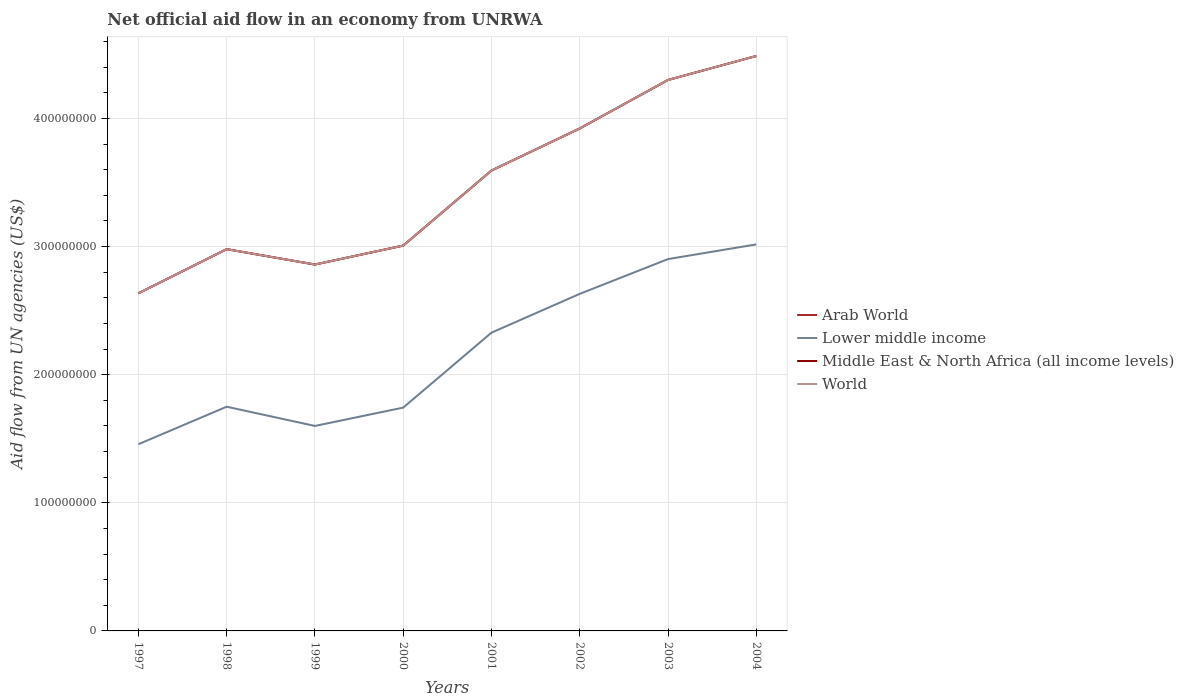Across all years, what is the maximum net official aid flow in Arab World?
Keep it short and to the point. 2.64e+08. In which year was the net official aid flow in Middle East & North Africa (all income levels) maximum?
Offer a terse response. 1997. What is the total net official aid flow in Lower middle income in the graph?
Offer a very short reply. -1.30e+08. What is the difference between the highest and the second highest net official aid flow in World?
Your response must be concise. 1.85e+08. What is the difference between two consecutive major ticks on the Y-axis?
Your answer should be compact. 1.00e+08. Are the values on the major ticks of Y-axis written in scientific E-notation?
Offer a terse response. No. Does the graph contain grids?
Give a very brief answer. Yes. Where does the legend appear in the graph?
Offer a very short reply. Center right. How many legend labels are there?
Keep it short and to the point. 4. What is the title of the graph?
Offer a terse response. Net official aid flow in an economy from UNRWA. What is the label or title of the X-axis?
Offer a terse response. Years. What is the label or title of the Y-axis?
Keep it short and to the point. Aid flow from UN agencies (US$). What is the Aid flow from UN agencies (US$) in Arab World in 1997?
Make the answer very short. 2.64e+08. What is the Aid flow from UN agencies (US$) of Lower middle income in 1997?
Your answer should be very brief. 1.46e+08. What is the Aid flow from UN agencies (US$) in Middle East & North Africa (all income levels) in 1997?
Provide a succinct answer. 2.64e+08. What is the Aid flow from UN agencies (US$) of World in 1997?
Your response must be concise. 2.64e+08. What is the Aid flow from UN agencies (US$) in Arab World in 1998?
Your answer should be compact. 2.98e+08. What is the Aid flow from UN agencies (US$) in Lower middle income in 1998?
Provide a short and direct response. 1.75e+08. What is the Aid flow from UN agencies (US$) of Middle East & North Africa (all income levels) in 1998?
Give a very brief answer. 2.98e+08. What is the Aid flow from UN agencies (US$) of World in 1998?
Your answer should be very brief. 2.98e+08. What is the Aid flow from UN agencies (US$) of Arab World in 1999?
Provide a short and direct response. 2.86e+08. What is the Aid flow from UN agencies (US$) of Lower middle income in 1999?
Ensure brevity in your answer.  1.60e+08. What is the Aid flow from UN agencies (US$) in Middle East & North Africa (all income levels) in 1999?
Keep it short and to the point. 2.86e+08. What is the Aid flow from UN agencies (US$) in World in 1999?
Keep it short and to the point. 2.86e+08. What is the Aid flow from UN agencies (US$) in Arab World in 2000?
Keep it short and to the point. 3.01e+08. What is the Aid flow from UN agencies (US$) in Lower middle income in 2000?
Your response must be concise. 1.74e+08. What is the Aid flow from UN agencies (US$) in Middle East & North Africa (all income levels) in 2000?
Your answer should be very brief. 3.01e+08. What is the Aid flow from UN agencies (US$) in World in 2000?
Offer a terse response. 3.01e+08. What is the Aid flow from UN agencies (US$) of Arab World in 2001?
Ensure brevity in your answer.  3.59e+08. What is the Aid flow from UN agencies (US$) in Lower middle income in 2001?
Ensure brevity in your answer.  2.33e+08. What is the Aid flow from UN agencies (US$) of Middle East & North Africa (all income levels) in 2001?
Ensure brevity in your answer.  3.59e+08. What is the Aid flow from UN agencies (US$) of World in 2001?
Your response must be concise. 3.59e+08. What is the Aid flow from UN agencies (US$) of Arab World in 2002?
Ensure brevity in your answer.  3.92e+08. What is the Aid flow from UN agencies (US$) in Lower middle income in 2002?
Offer a terse response. 2.63e+08. What is the Aid flow from UN agencies (US$) of Middle East & North Africa (all income levels) in 2002?
Keep it short and to the point. 3.92e+08. What is the Aid flow from UN agencies (US$) of World in 2002?
Make the answer very short. 3.92e+08. What is the Aid flow from UN agencies (US$) in Arab World in 2003?
Ensure brevity in your answer.  4.30e+08. What is the Aid flow from UN agencies (US$) of Lower middle income in 2003?
Provide a short and direct response. 2.90e+08. What is the Aid flow from UN agencies (US$) of Middle East & North Africa (all income levels) in 2003?
Offer a terse response. 4.30e+08. What is the Aid flow from UN agencies (US$) in World in 2003?
Offer a terse response. 4.30e+08. What is the Aid flow from UN agencies (US$) of Arab World in 2004?
Ensure brevity in your answer.  4.49e+08. What is the Aid flow from UN agencies (US$) in Lower middle income in 2004?
Make the answer very short. 3.02e+08. What is the Aid flow from UN agencies (US$) of Middle East & North Africa (all income levels) in 2004?
Provide a short and direct response. 4.49e+08. What is the Aid flow from UN agencies (US$) in World in 2004?
Provide a short and direct response. 4.49e+08. Across all years, what is the maximum Aid flow from UN agencies (US$) in Arab World?
Make the answer very short. 4.49e+08. Across all years, what is the maximum Aid flow from UN agencies (US$) in Lower middle income?
Give a very brief answer. 3.02e+08. Across all years, what is the maximum Aid flow from UN agencies (US$) in Middle East & North Africa (all income levels)?
Your response must be concise. 4.49e+08. Across all years, what is the maximum Aid flow from UN agencies (US$) of World?
Offer a terse response. 4.49e+08. Across all years, what is the minimum Aid flow from UN agencies (US$) in Arab World?
Keep it short and to the point. 2.64e+08. Across all years, what is the minimum Aid flow from UN agencies (US$) in Lower middle income?
Make the answer very short. 1.46e+08. Across all years, what is the minimum Aid flow from UN agencies (US$) of Middle East & North Africa (all income levels)?
Provide a succinct answer. 2.64e+08. Across all years, what is the minimum Aid flow from UN agencies (US$) of World?
Your response must be concise. 2.64e+08. What is the total Aid flow from UN agencies (US$) in Arab World in the graph?
Keep it short and to the point. 2.78e+09. What is the total Aid flow from UN agencies (US$) in Lower middle income in the graph?
Keep it short and to the point. 1.74e+09. What is the total Aid flow from UN agencies (US$) in Middle East & North Africa (all income levels) in the graph?
Make the answer very short. 2.78e+09. What is the total Aid flow from UN agencies (US$) of World in the graph?
Make the answer very short. 2.78e+09. What is the difference between the Aid flow from UN agencies (US$) of Arab World in 1997 and that in 1998?
Offer a terse response. -3.45e+07. What is the difference between the Aid flow from UN agencies (US$) of Lower middle income in 1997 and that in 1998?
Offer a terse response. -2.93e+07. What is the difference between the Aid flow from UN agencies (US$) in Middle East & North Africa (all income levels) in 1997 and that in 1998?
Make the answer very short. -3.45e+07. What is the difference between the Aid flow from UN agencies (US$) of World in 1997 and that in 1998?
Offer a terse response. -3.45e+07. What is the difference between the Aid flow from UN agencies (US$) of Arab World in 1997 and that in 1999?
Ensure brevity in your answer.  -2.25e+07. What is the difference between the Aid flow from UN agencies (US$) of Lower middle income in 1997 and that in 1999?
Your response must be concise. -1.43e+07. What is the difference between the Aid flow from UN agencies (US$) of Middle East & North Africa (all income levels) in 1997 and that in 1999?
Your answer should be compact. -2.25e+07. What is the difference between the Aid flow from UN agencies (US$) of World in 1997 and that in 1999?
Give a very brief answer. -2.25e+07. What is the difference between the Aid flow from UN agencies (US$) of Arab World in 1997 and that in 2000?
Offer a very short reply. -3.73e+07. What is the difference between the Aid flow from UN agencies (US$) of Lower middle income in 1997 and that in 2000?
Keep it short and to the point. -2.86e+07. What is the difference between the Aid flow from UN agencies (US$) in Middle East & North Africa (all income levels) in 1997 and that in 2000?
Your answer should be compact. -3.73e+07. What is the difference between the Aid flow from UN agencies (US$) of World in 1997 and that in 2000?
Make the answer very short. -3.73e+07. What is the difference between the Aid flow from UN agencies (US$) of Arab World in 1997 and that in 2001?
Give a very brief answer. -9.58e+07. What is the difference between the Aid flow from UN agencies (US$) in Lower middle income in 1997 and that in 2001?
Your answer should be compact. -8.71e+07. What is the difference between the Aid flow from UN agencies (US$) in Middle East & North Africa (all income levels) in 1997 and that in 2001?
Your response must be concise. -9.58e+07. What is the difference between the Aid flow from UN agencies (US$) of World in 1997 and that in 2001?
Keep it short and to the point. -9.58e+07. What is the difference between the Aid flow from UN agencies (US$) in Arab World in 1997 and that in 2002?
Offer a terse response. -1.29e+08. What is the difference between the Aid flow from UN agencies (US$) in Lower middle income in 1997 and that in 2002?
Make the answer very short. -1.17e+08. What is the difference between the Aid flow from UN agencies (US$) in Middle East & North Africa (all income levels) in 1997 and that in 2002?
Provide a short and direct response. -1.29e+08. What is the difference between the Aid flow from UN agencies (US$) in World in 1997 and that in 2002?
Your answer should be compact. -1.29e+08. What is the difference between the Aid flow from UN agencies (US$) of Arab World in 1997 and that in 2003?
Your answer should be very brief. -1.67e+08. What is the difference between the Aid flow from UN agencies (US$) in Lower middle income in 1997 and that in 2003?
Give a very brief answer. -1.45e+08. What is the difference between the Aid flow from UN agencies (US$) of Middle East & North Africa (all income levels) in 1997 and that in 2003?
Provide a succinct answer. -1.67e+08. What is the difference between the Aid flow from UN agencies (US$) in World in 1997 and that in 2003?
Your answer should be very brief. -1.67e+08. What is the difference between the Aid flow from UN agencies (US$) of Arab World in 1997 and that in 2004?
Your response must be concise. -1.85e+08. What is the difference between the Aid flow from UN agencies (US$) of Lower middle income in 1997 and that in 2004?
Offer a very short reply. -1.56e+08. What is the difference between the Aid flow from UN agencies (US$) in Middle East & North Africa (all income levels) in 1997 and that in 2004?
Offer a terse response. -1.85e+08. What is the difference between the Aid flow from UN agencies (US$) of World in 1997 and that in 2004?
Give a very brief answer. -1.85e+08. What is the difference between the Aid flow from UN agencies (US$) of Lower middle income in 1998 and that in 1999?
Offer a terse response. 1.50e+07. What is the difference between the Aid flow from UN agencies (US$) of Arab World in 1998 and that in 2000?
Your response must be concise. -2.78e+06. What is the difference between the Aid flow from UN agencies (US$) of Lower middle income in 1998 and that in 2000?
Keep it short and to the point. 6.90e+05. What is the difference between the Aid flow from UN agencies (US$) of Middle East & North Africa (all income levels) in 1998 and that in 2000?
Give a very brief answer. -2.78e+06. What is the difference between the Aid flow from UN agencies (US$) of World in 1998 and that in 2000?
Provide a succinct answer. -2.78e+06. What is the difference between the Aid flow from UN agencies (US$) in Arab World in 1998 and that in 2001?
Offer a very short reply. -6.14e+07. What is the difference between the Aid flow from UN agencies (US$) of Lower middle income in 1998 and that in 2001?
Keep it short and to the point. -5.78e+07. What is the difference between the Aid flow from UN agencies (US$) of Middle East & North Africa (all income levels) in 1998 and that in 2001?
Your answer should be compact. -6.14e+07. What is the difference between the Aid flow from UN agencies (US$) in World in 1998 and that in 2001?
Provide a short and direct response. -6.14e+07. What is the difference between the Aid flow from UN agencies (US$) in Arab World in 1998 and that in 2002?
Provide a short and direct response. -9.42e+07. What is the difference between the Aid flow from UN agencies (US$) in Lower middle income in 1998 and that in 2002?
Your answer should be compact. -8.81e+07. What is the difference between the Aid flow from UN agencies (US$) of Middle East & North Africa (all income levels) in 1998 and that in 2002?
Keep it short and to the point. -9.42e+07. What is the difference between the Aid flow from UN agencies (US$) in World in 1998 and that in 2002?
Make the answer very short. -9.42e+07. What is the difference between the Aid flow from UN agencies (US$) of Arab World in 1998 and that in 2003?
Ensure brevity in your answer.  -1.32e+08. What is the difference between the Aid flow from UN agencies (US$) of Lower middle income in 1998 and that in 2003?
Keep it short and to the point. -1.15e+08. What is the difference between the Aid flow from UN agencies (US$) of Middle East & North Africa (all income levels) in 1998 and that in 2003?
Provide a short and direct response. -1.32e+08. What is the difference between the Aid flow from UN agencies (US$) of World in 1998 and that in 2003?
Provide a succinct answer. -1.32e+08. What is the difference between the Aid flow from UN agencies (US$) in Arab World in 1998 and that in 2004?
Provide a short and direct response. -1.51e+08. What is the difference between the Aid flow from UN agencies (US$) in Lower middle income in 1998 and that in 2004?
Provide a short and direct response. -1.27e+08. What is the difference between the Aid flow from UN agencies (US$) in Middle East & North Africa (all income levels) in 1998 and that in 2004?
Ensure brevity in your answer.  -1.51e+08. What is the difference between the Aid flow from UN agencies (US$) in World in 1998 and that in 2004?
Provide a succinct answer. -1.51e+08. What is the difference between the Aid flow from UN agencies (US$) of Arab World in 1999 and that in 2000?
Keep it short and to the point. -1.48e+07. What is the difference between the Aid flow from UN agencies (US$) of Lower middle income in 1999 and that in 2000?
Provide a short and direct response. -1.43e+07. What is the difference between the Aid flow from UN agencies (US$) in Middle East & North Africa (all income levels) in 1999 and that in 2000?
Provide a succinct answer. -1.48e+07. What is the difference between the Aid flow from UN agencies (US$) in World in 1999 and that in 2000?
Offer a terse response. -1.48e+07. What is the difference between the Aid flow from UN agencies (US$) in Arab World in 1999 and that in 2001?
Offer a very short reply. -7.34e+07. What is the difference between the Aid flow from UN agencies (US$) in Lower middle income in 1999 and that in 2001?
Ensure brevity in your answer.  -7.28e+07. What is the difference between the Aid flow from UN agencies (US$) in Middle East & North Africa (all income levels) in 1999 and that in 2001?
Ensure brevity in your answer.  -7.34e+07. What is the difference between the Aid flow from UN agencies (US$) of World in 1999 and that in 2001?
Offer a terse response. -7.34e+07. What is the difference between the Aid flow from UN agencies (US$) of Arab World in 1999 and that in 2002?
Your answer should be compact. -1.06e+08. What is the difference between the Aid flow from UN agencies (US$) in Lower middle income in 1999 and that in 2002?
Ensure brevity in your answer.  -1.03e+08. What is the difference between the Aid flow from UN agencies (US$) in Middle East & North Africa (all income levels) in 1999 and that in 2002?
Give a very brief answer. -1.06e+08. What is the difference between the Aid flow from UN agencies (US$) in World in 1999 and that in 2002?
Your response must be concise. -1.06e+08. What is the difference between the Aid flow from UN agencies (US$) in Arab World in 1999 and that in 2003?
Give a very brief answer. -1.44e+08. What is the difference between the Aid flow from UN agencies (US$) in Lower middle income in 1999 and that in 2003?
Make the answer very short. -1.30e+08. What is the difference between the Aid flow from UN agencies (US$) of Middle East & North Africa (all income levels) in 1999 and that in 2003?
Offer a terse response. -1.44e+08. What is the difference between the Aid flow from UN agencies (US$) of World in 1999 and that in 2003?
Make the answer very short. -1.44e+08. What is the difference between the Aid flow from UN agencies (US$) in Arab World in 1999 and that in 2004?
Give a very brief answer. -1.63e+08. What is the difference between the Aid flow from UN agencies (US$) of Lower middle income in 1999 and that in 2004?
Offer a very short reply. -1.42e+08. What is the difference between the Aid flow from UN agencies (US$) of Middle East & North Africa (all income levels) in 1999 and that in 2004?
Offer a terse response. -1.63e+08. What is the difference between the Aid flow from UN agencies (US$) in World in 1999 and that in 2004?
Provide a short and direct response. -1.63e+08. What is the difference between the Aid flow from UN agencies (US$) in Arab World in 2000 and that in 2001?
Offer a terse response. -5.86e+07. What is the difference between the Aid flow from UN agencies (US$) in Lower middle income in 2000 and that in 2001?
Make the answer very short. -5.85e+07. What is the difference between the Aid flow from UN agencies (US$) of Middle East & North Africa (all income levels) in 2000 and that in 2001?
Your answer should be compact. -5.86e+07. What is the difference between the Aid flow from UN agencies (US$) in World in 2000 and that in 2001?
Keep it short and to the point. -5.86e+07. What is the difference between the Aid flow from UN agencies (US$) of Arab World in 2000 and that in 2002?
Make the answer very short. -9.14e+07. What is the difference between the Aid flow from UN agencies (US$) in Lower middle income in 2000 and that in 2002?
Offer a very short reply. -8.88e+07. What is the difference between the Aid flow from UN agencies (US$) in Middle East & North Africa (all income levels) in 2000 and that in 2002?
Your answer should be very brief. -9.14e+07. What is the difference between the Aid flow from UN agencies (US$) in World in 2000 and that in 2002?
Provide a succinct answer. -9.14e+07. What is the difference between the Aid flow from UN agencies (US$) of Arab World in 2000 and that in 2003?
Ensure brevity in your answer.  -1.29e+08. What is the difference between the Aid flow from UN agencies (US$) of Lower middle income in 2000 and that in 2003?
Your answer should be compact. -1.16e+08. What is the difference between the Aid flow from UN agencies (US$) of Middle East & North Africa (all income levels) in 2000 and that in 2003?
Keep it short and to the point. -1.29e+08. What is the difference between the Aid flow from UN agencies (US$) of World in 2000 and that in 2003?
Your answer should be very brief. -1.29e+08. What is the difference between the Aid flow from UN agencies (US$) of Arab World in 2000 and that in 2004?
Make the answer very short. -1.48e+08. What is the difference between the Aid flow from UN agencies (US$) in Lower middle income in 2000 and that in 2004?
Your answer should be very brief. -1.27e+08. What is the difference between the Aid flow from UN agencies (US$) in Middle East & North Africa (all income levels) in 2000 and that in 2004?
Offer a terse response. -1.48e+08. What is the difference between the Aid flow from UN agencies (US$) in World in 2000 and that in 2004?
Make the answer very short. -1.48e+08. What is the difference between the Aid flow from UN agencies (US$) of Arab World in 2001 and that in 2002?
Give a very brief answer. -3.28e+07. What is the difference between the Aid flow from UN agencies (US$) of Lower middle income in 2001 and that in 2002?
Offer a very short reply. -3.03e+07. What is the difference between the Aid flow from UN agencies (US$) of Middle East & North Africa (all income levels) in 2001 and that in 2002?
Make the answer very short. -3.28e+07. What is the difference between the Aid flow from UN agencies (US$) of World in 2001 and that in 2002?
Give a very brief answer. -3.28e+07. What is the difference between the Aid flow from UN agencies (US$) in Arab World in 2001 and that in 2003?
Provide a short and direct response. -7.07e+07. What is the difference between the Aid flow from UN agencies (US$) of Lower middle income in 2001 and that in 2003?
Provide a succinct answer. -5.74e+07. What is the difference between the Aid flow from UN agencies (US$) of Middle East & North Africa (all income levels) in 2001 and that in 2003?
Keep it short and to the point. -7.07e+07. What is the difference between the Aid flow from UN agencies (US$) of World in 2001 and that in 2003?
Make the answer very short. -7.07e+07. What is the difference between the Aid flow from UN agencies (US$) in Arab World in 2001 and that in 2004?
Offer a terse response. -8.94e+07. What is the difference between the Aid flow from UN agencies (US$) of Lower middle income in 2001 and that in 2004?
Offer a terse response. -6.89e+07. What is the difference between the Aid flow from UN agencies (US$) in Middle East & North Africa (all income levels) in 2001 and that in 2004?
Offer a terse response. -8.94e+07. What is the difference between the Aid flow from UN agencies (US$) of World in 2001 and that in 2004?
Provide a short and direct response. -8.94e+07. What is the difference between the Aid flow from UN agencies (US$) in Arab World in 2002 and that in 2003?
Make the answer very short. -3.79e+07. What is the difference between the Aid flow from UN agencies (US$) of Lower middle income in 2002 and that in 2003?
Provide a short and direct response. -2.72e+07. What is the difference between the Aid flow from UN agencies (US$) in Middle East & North Africa (all income levels) in 2002 and that in 2003?
Provide a succinct answer. -3.79e+07. What is the difference between the Aid flow from UN agencies (US$) of World in 2002 and that in 2003?
Your answer should be very brief. -3.79e+07. What is the difference between the Aid flow from UN agencies (US$) in Arab World in 2002 and that in 2004?
Offer a terse response. -5.66e+07. What is the difference between the Aid flow from UN agencies (US$) in Lower middle income in 2002 and that in 2004?
Give a very brief answer. -3.86e+07. What is the difference between the Aid flow from UN agencies (US$) of Middle East & North Africa (all income levels) in 2002 and that in 2004?
Your answer should be very brief. -5.66e+07. What is the difference between the Aid flow from UN agencies (US$) of World in 2002 and that in 2004?
Keep it short and to the point. -5.66e+07. What is the difference between the Aid flow from UN agencies (US$) of Arab World in 2003 and that in 2004?
Provide a short and direct response. -1.87e+07. What is the difference between the Aid flow from UN agencies (US$) of Lower middle income in 2003 and that in 2004?
Your answer should be very brief. -1.15e+07. What is the difference between the Aid flow from UN agencies (US$) of Middle East & North Africa (all income levels) in 2003 and that in 2004?
Your answer should be very brief. -1.87e+07. What is the difference between the Aid flow from UN agencies (US$) of World in 2003 and that in 2004?
Offer a terse response. -1.87e+07. What is the difference between the Aid flow from UN agencies (US$) of Arab World in 1997 and the Aid flow from UN agencies (US$) of Lower middle income in 1998?
Your answer should be very brief. 8.85e+07. What is the difference between the Aid flow from UN agencies (US$) of Arab World in 1997 and the Aid flow from UN agencies (US$) of Middle East & North Africa (all income levels) in 1998?
Your response must be concise. -3.45e+07. What is the difference between the Aid flow from UN agencies (US$) of Arab World in 1997 and the Aid flow from UN agencies (US$) of World in 1998?
Your answer should be very brief. -3.45e+07. What is the difference between the Aid flow from UN agencies (US$) of Lower middle income in 1997 and the Aid flow from UN agencies (US$) of Middle East & North Africa (all income levels) in 1998?
Give a very brief answer. -1.52e+08. What is the difference between the Aid flow from UN agencies (US$) of Lower middle income in 1997 and the Aid flow from UN agencies (US$) of World in 1998?
Give a very brief answer. -1.52e+08. What is the difference between the Aid flow from UN agencies (US$) of Middle East & North Africa (all income levels) in 1997 and the Aid flow from UN agencies (US$) of World in 1998?
Your answer should be compact. -3.45e+07. What is the difference between the Aid flow from UN agencies (US$) in Arab World in 1997 and the Aid flow from UN agencies (US$) in Lower middle income in 1999?
Ensure brevity in your answer.  1.04e+08. What is the difference between the Aid flow from UN agencies (US$) of Arab World in 1997 and the Aid flow from UN agencies (US$) of Middle East & North Africa (all income levels) in 1999?
Offer a very short reply. -2.25e+07. What is the difference between the Aid flow from UN agencies (US$) of Arab World in 1997 and the Aid flow from UN agencies (US$) of World in 1999?
Your answer should be compact. -2.25e+07. What is the difference between the Aid flow from UN agencies (US$) in Lower middle income in 1997 and the Aid flow from UN agencies (US$) in Middle East & North Africa (all income levels) in 1999?
Your answer should be compact. -1.40e+08. What is the difference between the Aid flow from UN agencies (US$) in Lower middle income in 1997 and the Aid flow from UN agencies (US$) in World in 1999?
Offer a terse response. -1.40e+08. What is the difference between the Aid flow from UN agencies (US$) of Middle East & North Africa (all income levels) in 1997 and the Aid flow from UN agencies (US$) of World in 1999?
Your answer should be very brief. -2.25e+07. What is the difference between the Aid flow from UN agencies (US$) in Arab World in 1997 and the Aid flow from UN agencies (US$) in Lower middle income in 2000?
Give a very brief answer. 8.92e+07. What is the difference between the Aid flow from UN agencies (US$) in Arab World in 1997 and the Aid flow from UN agencies (US$) in Middle East & North Africa (all income levels) in 2000?
Your response must be concise. -3.73e+07. What is the difference between the Aid flow from UN agencies (US$) of Arab World in 1997 and the Aid flow from UN agencies (US$) of World in 2000?
Provide a short and direct response. -3.73e+07. What is the difference between the Aid flow from UN agencies (US$) of Lower middle income in 1997 and the Aid flow from UN agencies (US$) of Middle East & North Africa (all income levels) in 2000?
Provide a short and direct response. -1.55e+08. What is the difference between the Aid flow from UN agencies (US$) in Lower middle income in 1997 and the Aid flow from UN agencies (US$) in World in 2000?
Offer a terse response. -1.55e+08. What is the difference between the Aid flow from UN agencies (US$) of Middle East & North Africa (all income levels) in 1997 and the Aid flow from UN agencies (US$) of World in 2000?
Provide a succinct answer. -3.73e+07. What is the difference between the Aid flow from UN agencies (US$) in Arab World in 1997 and the Aid flow from UN agencies (US$) in Lower middle income in 2001?
Offer a very short reply. 3.07e+07. What is the difference between the Aid flow from UN agencies (US$) in Arab World in 1997 and the Aid flow from UN agencies (US$) in Middle East & North Africa (all income levels) in 2001?
Make the answer very short. -9.58e+07. What is the difference between the Aid flow from UN agencies (US$) of Arab World in 1997 and the Aid flow from UN agencies (US$) of World in 2001?
Ensure brevity in your answer.  -9.58e+07. What is the difference between the Aid flow from UN agencies (US$) of Lower middle income in 1997 and the Aid flow from UN agencies (US$) of Middle East & North Africa (all income levels) in 2001?
Keep it short and to the point. -2.14e+08. What is the difference between the Aid flow from UN agencies (US$) in Lower middle income in 1997 and the Aid flow from UN agencies (US$) in World in 2001?
Your answer should be compact. -2.14e+08. What is the difference between the Aid flow from UN agencies (US$) in Middle East & North Africa (all income levels) in 1997 and the Aid flow from UN agencies (US$) in World in 2001?
Provide a short and direct response. -9.58e+07. What is the difference between the Aid flow from UN agencies (US$) in Arab World in 1997 and the Aid flow from UN agencies (US$) in Lower middle income in 2002?
Keep it short and to the point. 4.20e+05. What is the difference between the Aid flow from UN agencies (US$) in Arab World in 1997 and the Aid flow from UN agencies (US$) in Middle East & North Africa (all income levels) in 2002?
Offer a very short reply. -1.29e+08. What is the difference between the Aid flow from UN agencies (US$) of Arab World in 1997 and the Aid flow from UN agencies (US$) of World in 2002?
Your response must be concise. -1.29e+08. What is the difference between the Aid flow from UN agencies (US$) of Lower middle income in 1997 and the Aid flow from UN agencies (US$) of Middle East & North Africa (all income levels) in 2002?
Your answer should be very brief. -2.46e+08. What is the difference between the Aid flow from UN agencies (US$) in Lower middle income in 1997 and the Aid flow from UN agencies (US$) in World in 2002?
Offer a very short reply. -2.46e+08. What is the difference between the Aid flow from UN agencies (US$) of Middle East & North Africa (all income levels) in 1997 and the Aid flow from UN agencies (US$) of World in 2002?
Offer a very short reply. -1.29e+08. What is the difference between the Aid flow from UN agencies (US$) in Arab World in 1997 and the Aid flow from UN agencies (US$) in Lower middle income in 2003?
Make the answer very short. -2.67e+07. What is the difference between the Aid flow from UN agencies (US$) of Arab World in 1997 and the Aid flow from UN agencies (US$) of Middle East & North Africa (all income levels) in 2003?
Provide a succinct answer. -1.67e+08. What is the difference between the Aid flow from UN agencies (US$) in Arab World in 1997 and the Aid flow from UN agencies (US$) in World in 2003?
Ensure brevity in your answer.  -1.67e+08. What is the difference between the Aid flow from UN agencies (US$) in Lower middle income in 1997 and the Aid flow from UN agencies (US$) in Middle East & North Africa (all income levels) in 2003?
Ensure brevity in your answer.  -2.84e+08. What is the difference between the Aid flow from UN agencies (US$) of Lower middle income in 1997 and the Aid flow from UN agencies (US$) of World in 2003?
Make the answer very short. -2.84e+08. What is the difference between the Aid flow from UN agencies (US$) of Middle East & North Africa (all income levels) in 1997 and the Aid flow from UN agencies (US$) of World in 2003?
Offer a very short reply. -1.67e+08. What is the difference between the Aid flow from UN agencies (US$) in Arab World in 1997 and the Aid flow from UN agencies (US$) in Lower middle income in 2004?
Your answer should be compact. -3.82e+07. What is the difference between the Aid flow from UN agencies (US$) of Arab World in 1997 and the Aid flow from UN agencies (US$) of Middle East & North Africa (all income levels) in 2004?
Give a very brief answer. -1.85e+08. What is the difference between the Aid flow from UN agencies (US$) of Arab World in 1997 and the Aid flow from UN agencies (US$) of World in 2004?
Provide a short and direct response. -1.85e+08. What is the difference between the Aid flow from UN agencies (US$) of Lower middle income in 1997 and the Aid flow from UN agencies (US$) of Middle East & North Africa (all income levels) in 2004?
Keep it short and to the point. -3.03e+08. What is the difference between the Aid flow from UN agencies (US$) of Lower middle income in 1997 and the Aid flow from UN agencies (US$) of World in 2004?
Ensure brevity in your answer.  -3.03e+08. What is the difference between the Aid flow from UN agencies (US$) of Middle East & North Africa (all income levels) in 1997 and the Aid flow from UN agencies (US$) of World in 2004?
Offer a terse response. -1.85e+08. What is the difference between the Aid flow from UN agencies (US$) of Arab World in 1998 and the Aid flow from UN agencies (US$) of Lower middle income in 1999?
Your answer should be compact. 1.38e+08. What is the difference between the Aid flow from UN agencies (US$) of Arab World in 1998 and the Aid flow from UN agencies (US$) of Middle East & North Africa (all income levels) in 1999?
Your answer should be compact. 1.20e+07. What is the difference between the Aid flow from UN agencies (US$) in Arab World in 1998 and the Aid flow from UN agencies (US$) in World in 1999?
Make the answer very short. 1.20e+07. What is the difference between the Aid flow from UN agencies (US$) of Lower middle income in 1998 and the Aid flow from UN agencies (US$) of Middle East & North Africa (all income levels) in 1999?
Keep it short and to the point. -1.11e+08. What is the difference between the Aid flow from UN agencies (US$) of Lower middle income in 1998 and the Aid flow from UN agencies (US$) of World in 1999?
Give a very brief answer. -1.11e+08. What is the difference between the Aid flow from UN agencies (US$) in Arab World in 1998 and the Aid flow from UN agencies (US$) in Lower middle income in 2000?
Your answer should be very brief. 1.24e+08. What is the difference between the Aid flow from UN agencies (US$) of Arab World in 1998 and the Aid flow from UN agencies (US$) of Middle East & North Africa (all income levels) in 2000?
Your answer should be compact. -2.78e+06. What is the difference between the Aid flow from UN agencies (US$) in Arab World in 1998 and the Aid flow from UN agencies (US$) in World in 2000?
Offer a terse response. -2.78e+06. What is the difference between the Aid flow from UN agencies (US$) of Lower middle income in 1998 and the Aid flow from UN agencies (US$) of Middle East & North Africa (all income levels) in 2000?
Your answer should be very brief. -1.26e+08. What is the difference between the Aid flow from UN agencies (US$) of Lower middle income in 1998 and the Aid flow from UN agencies (US$) of World in 2000?
Your response must be concise. -1.26e+08. What is the difference between the Aid flow from UN agencies (US$) in Middle East & North Africa (all income levels) in 1998 and the Aid flow from UN agencies (US$) in World in 2000?
Provide a succinct answer. -2.78e+06. What is the difference between the Aid flow from UN agencies (US$) in Arab World in 1998 and the Aid flow from UN agencies (US$) in Lower middle income in 2001?
Your response must be concise. 6.52e+07. What is the difference between the Aid flow from UN agencies (US$) in Arab World in 1998 and the Aid flow from UN agencies (US$) in Middle East & North Africa (all income levels) in 2001?
Make the answer very short. -6.14e+07. What is the difference between the Aid flow from UN agencies (US$) in Arab World in 1998 and the Aid flow from UN agencies (US$) in World in 2001?
Your response must be concise. -6.14e+07. What is the difference between the Aid flow from UN agencies (US$) of Lower middle income in 1998 and the Aid flow from UN agencies (US$) of Middle East & North Africa (all income levels) in 2001?
Your answer should be compact. -1.84e+08. What is the difference between the Aid flow from UN agencies (US$) of Lower middle income in 1998 and the Aid flow from UN agencies (US$) of World in 2001?
Keep it short and to the point. -1.84e+08. What is the difference between the Aid flow from UN agencies (US$) of Middle East & North Africa (all income levels) in 1998 and the Aid flow from UN agencies (US$) of World in 2001?
Provide a succinct answer. -6.14e+07. What is the difference between the Aid flow from UN agencies (US$) in Arab World in 1998 and the Aid flow from UN agencies (US$) in Lower middle income in 2002?
Provide a short and direct response. 3.49e+07. What is the difference between the Aid flow from UN agencies (US$) of Arab World in 1998 and the Aid flow from UN agencies (US$) of Middle East & North Africa (all income levels) in 2002?
Offer a terse response. -9.42e+07. What is the difference between the Aid flow from UN agencies (US$) in Arab World in 1998 and the Aid flow from UN agencies (US$) in World in 2002?
Your answer should be compact. -9.42e+07. What is the difference between the Aid flow from UN agencies (US$) in Lower middle income in 1998 and the Aid flow from UN agencies (US$) in Middle East & North Africa (all income levels) in 2002?
Your answer should be compact. -2.17e+08. What is the difference between the Aid flow from UN agencies (US$) of Lower middle income in 1998 and the Aid flow from UN agencies (US$) of World in 2002?
Make the answer very short. -2.17e+08. What is the difference between the Aid flow from UN agencies (US$) of Middle East & North Africa (all income levels) in 1998 and the Aid flow from UN agencies (US$) of World in 2002?
Your answer should be very brief. -9.42e+07. What is the difference between the Aid flow from UN agencies (US$) in Arab World in 1998 and the Aid flow from UN agencies (US$) in Lower middle income in 2003?
Ensure brevity in your answer.  7.75e+06. What is the difference between the Aid flow from UN agencies (US$) in Arab World in 1998 and the Aid flow from UN agencies (US$) in Middle East & North Africa (all income levels) in 2003?
Your answer should be very brief. -1.32e+08. What is the difference between the Aid flow from UN agencies (US$) in Arab World in 1998 and the Aid flow from UN agencies (US$) in World in 2003?
Give a very brief answer. -1.32e+08. What is the difference between the Aid flow from UN agencies (US$) of Lower middle income in 1998 and the Aid flow from UN agencies (US$) of Middle East & North Africa (all income levels) in 2003?
Your answer should be very brief. -2.55e+08. What is the difference between the Aid flow from UN agencies (US$) in Lower middle income in 1998 and the Aid flow from UN agencies (US$) in World in 2003?
Give a very brief answer. -2.55e+08. What is the difference between the Aid flow from UN agencies (US$) of Middle East & North Africa (all income levels) in 1998 and the Aid flow from UN agencies (US$) of World in 2003?
Make the answer very short. -1.32e+08. What is the difference between the Aid flow from UN agencies (US$) of Arab World in 1998 and the Aid flow from UN agencies (US$) of Lower middle income in 2004?
Offer a very short reply. -3.71e+06. What is the difference between the Aid flow from UN agencies (US$) in Arab World in 1998 and the Aid flow from UN agencies (US$) in Middle East & North Africa (all income levels) in 2004?
Ensure brevity in your answer.  -1.51e+08. What is the difference between the Aid flow from UN agencies (US$) in Arab World in 1998 and the Aid flow from UN agencies (US$) in World in 2004?
Your answer should be compact. -1.51e+08. What is the difference between the Aid flow from UN agencies (US$) of Lower middle income in 1998 and the Aid flow from UN agencies (US$) of Middle East & North Africa (all income levels) in 2004?
Offer a very short reply. -2.74e+08. What is the difference between the Aid flow from UN agencies (US$) in Lower middle income in 1998 and the Aid flow from UN agencies (US$) in World in 2004?
Provide a short and direct response. -2.74e+08. What is the difference between the Aid flow from UN agencies (US$) in Middle East & North Africa (all income levels) in 1998 and the Aid flow from UN agencies (US$) in World in 2004?
Your answer should be compact. -1.51e+08. What is the difference between the Aid flow from UN agencies (US$) of Arab World in 1999 and the Aid flow from UN agencies (US$) of Lower middle income in 2000?
Offer a very short reply. 1.12e+08. What is the difference between the Aid flow from UN agencies (US$) of Arab World in 1999 and the Aid flow from UN agencies (US$) of Middle East & North Africa (all income levels) in 2000?
Keep it short and to the point. -1.48e+07. What is the difference between the Aid flow from UN agencies (US$) of Arab World in 1999 and the Aid flow from UN agencies (US$) of World in 2000?
Provide a short and direct response. -1.48e+07. What is the difference between the Aid flow from UN agencies (US$) of Lower middle income in 1999 and the Aid flow from UN agencies (US$) of Middle East & North Africa (all income levels) in 2000?
Provide a short and direct response. -1.41e+08. What is the difference between the Aid flow from UN agencies (US$) in Lower middle income in 1999 and the Aid flow from UN agencies (US$) in World in 2000?
Your response must be concise. -1.41e+08. What is the difference between the Aid flow from UN agencies (US$) of Middle East & North Africa (all income levels) in 1999 and the Aid flow from UN agencies (US$) of World in 2000?
Offer a very short reply. -1.48e+07. What is the difference between the Aid flow from UN agencies (US$) in Arab World in 1999 and the Aid flow from UN agencies (US$) in Lower middle income in 2001?
Provide a short and direct response. 5.32e+07. What is the difference between the Aid flow from UN agencies (US$) in Arab World in 1999 and the Aid flow from UN agencies (US$) in Middle East & North Africa (all income levels) in 2001?
Ensure brevity in your answer.  -7.34e+07. What is the difference between the Aid flow from UN agencies (US$) in Arab World in 1999 and the Aid flow from UN agencies (US$) in World in 2001?
Your answer should be very brief. -7.34e+07. What is the difference between the Aid flow from UN agencies (US$) in Lower middle income in 1999 and the Aid flow from UN agencies (US$) in Middle East & North Africa (all income levels) in 2001?
Your answer should be compact. -1.99e+08. What is the difference between the Aid flow from UN agencies (US$) in Lower middle income in 1999 and the Aid flow from UN agencies (US$) in World in 2001?
Your answer should be compact. -1.99e+08. What is the difference between the Aid flow from UN agencies (US$) of Middle East & North Africa (all income levels) in 1999 and the Aid flow from UN agencies (US$) of World in 2001?
Provide a succinct answer. -7.34e+07. What is the difference between the Aid flow from UN agencies (US$) of Arab World in 1999 and the Aid flow from UN agencies (US$) of Lower middle income in 2002?
Give a very brief answer. 2.29e+07. What is the difference between the Aid flow from UN agencies (US$) of Arab World in 1999 and the Aid flow from UN agencies (US$) of Middle East & North Africa (all income levels) in 2002?
Your answer should be very brief. -1.06e+08. What is the difference between the Aid flow from UN agencies (US$) in Arab World in 1999 and the Aid flow from UN agencies (US$) in World in 2002?
Your answer should be compact. -1.06e+08. What is the difference between the Aid flow from UN agencies (US$) of Lower middle income in 1999 and the Aid flow from UN agencies (US$) of Middle East & North Africa (all income levels) in 2002?
Your answer should be very brief. -2.32e+08. What is the difference between the Aid flow from UN agencies (US$) in Lower middle income in 1999 and the Aid flow from UN agencies (US$) in World in 2002?
Keep it short and to the point. -2.32e+08. What is the difference between the Aid flow from UN agencies (US$) of Middle East & North Africa (all income levels) in 1999 and the Aid flow from UN agencies (US$) of World in 2002?
Your answer should be compact. -1.06e+08. What is the difference between the Aid flow from UN agencies (US$) in Arab World in 1999 and the Aid flow from UN agencies (US$) in Lower middle income in 2003?
Your answer should be very brief. -4.25e+06. What is the difference between the Aid flow from UN agencies (US$) of Arab World in 1999 and the Aid flow from UN agencies (US$) of Middle East & North Africa (all income levels) in 2003?
Provide a succinct answer. -1.44e+08. What is the difference between the Aid flow from UN agencies (US$) of Arab World in 1999 and the Aid flow from UN agencies (US$) of World in 2003?
Provide a short and direct response. -1.44e+08. What is the difference between the Aid flow from UN agencies (US$) of Lower middle income in 1999 and the Aid flow from UN agencies (US$) of Middle East & North Africa (all income levels) in 2003?
Provide a short and direct response. -2.70e+08. What is the difference between the Aid flow from UN agencies (US$) in Lower middle income in 1999 and the Aid flow from UN agencies (US$) in World in 2003?
Provide a succinct answer. -2.70e+08. What is the difference between the Aid flow from UN agencies (US$) of Middle East & North Africa (all income levels) in 1999 and the Aid flow from UN agencies (US$) of World in 2003?
Give a very brief answer. -1.44e+08. What is the difference between the Aid flow from UN agencies (US$) in Arab World in 1999 and the Aid flow from UN agencies (US$) in Lower middle income in 2004?
Give a very brief answer. -1.57e+07. What is the difference between the Aid flow from UN agencies (US$) of Arab World in 1999 and the Aid flow from UN agencies (US$) of Middle East & North Africa (all income levels) in 2004?
Provide a succinct answer. -1.63e+08. What is the difference between the Aid flow from UN agencies (US$) in Arab World in 1999 and the Aid flow from UN agencies (US$) in World in 2004?
Your response must be concise. -1.63e+08. What is the difference between the Aid flow from UN agencies (US$) of Lower middle income in 1999 and the Aid flow from UN agencies (US$) of Middle East & North Africa (all income levels) in 2004?
Provide a succinct answer. -2.89e+08. What is the difference between the Aid flow from UN agencies (US$) of Lower middle income in 1999 and the Aid flow from UN agencies (US$) of World in 2004?
Keep it short and to the point. -2.89e+08. What is the difference between the Aid flow from UN agencies (US$) of Middle East & North Africa (all income levels) in 1999 and the Aid flow from UN agencies (US$) of World in 2004?
Make the answer very short. -1.63e+08. What is the difference between the Aid flow from UN agencies (US$) of Arab World in 2000 and the Aid flow from UN agencies (US$) of Lower middle income in 2001?
Your response must be concise. 6.80e+07. What is the difference between the Aid flow from UN agencies (US$) in Arab World in 2000 and the Aid flow from UN agencies (US$) in Middle East & North Africa (all income levels) in 2001?
Your answer should be compact. -5.86e+07. What is the difference between the Aid flow from UN agencies (US$) in Arab World in 2000 and the Aid flow from UN agencies (US$) in World in 2001?
Provide a short and direct response. -5.86e+07. What is the difference between the Aid flow from UN agencies (US$) of Lower middle income in 2000 and the Aid flow from UN agencies (US$) of Middle East & North Africa (all income levels) in 2001?
Your answer should be very brief. -1.85e+08. What is the difference between the Aid flow from UN agencies (US$) in Lower middle income in 2000 and the Aid flow from UN agencies (US$) in World in 2001?
Your answer should be very brief. -1.85e+08. What is the difference between the Aid flow from UN agencies (US$) in Middle East & North Africa (all income levels) in 2000 and the Aid flow from UN agencies (US$) in World in 2001?
Keep it short and to the point. -5.86e+07. What is the difference between the Aid flow from UN agencies (US$) in Arab World in 2000 and the Aid flow from UN agencies (US$) in Lower middle income in 2002?
Offer a terse response. 3.77e+07. What is the difference between the Aid flow from UN agencies (US$) of Arab World in 2000 and the Aid flow from UN agencies (US$) of Middle East & North Africa (all income levels) in 2002?
Keep it short and to the point. -9.14e+07. What is the difference between the Aid flow from UN agencies (US$) of Arab World in 2000 and the Aid flow from UN agencies (US$) of World in 2002?
Make the answer very short. -9.14e+07. What is the difference between the Aid flow from UN agencies (US$) in Lower middle income in 2000 and the Aid flow from UN agencies (US$) in Middle East & North Africa (all income levels) in 2002?
Keep it short and to the point. -2.18e+08. What is the difference between the Aid flow from UN agencies (US$) of Lower middle income in 2000 and the Aid flow from UN agencies (US$) of World in 2002?
Keep it short and to the point. -2.18e+08. What is the difference between the Aid flow from UN agencies (US$) of Middle East & North Africa (all income levels) in 2000 and the Aid flow from UN agencies (US$) of World in 2002?
Give a very brief answer. -9.14e+07. What is the difference between the Aid flow from UN agencies (US$) in Arab World in 2000 and the Aid flow from UN agencies (US$) in Lower middle income in 2003?
Provide a short and direct response. 1.05e+07. What is the difference between the Aid flow from UN agencies (US$) in Arab World in 2000 and the Aid flow from UN agencies (US$) in Middle East & North Africa (all income levels) in 2003?
Your answer should be compact. -1.29e+08. What is the difference between the Aid flow from UN agencies (US$) of Arab World in 2000 and the Aid flow from UN agencies (US$) of World in 2003?
Give a very brief answer. -1.29e+08. What is the difference between the Aid flow from UN agencies (US$) of Lower middle income in 2000 and the Aid flow from UN agencies (US$) of Middle East & North Africa (all income levels) in 2003?
Your answer should be compact. -2.56e+08. What is the difference between the Aid flow from UN agencies (US$) of Lower middle income in 2000 and the Aid flow from UN agencies (US$) of World in 2003?
Give a very brief answer. -2.56e+08. What is the difference between the Aid flow from UN agencies (US$) in Middle East & North Africa (all income levels) in 2000 and the Aid flow from UN agencies (US$) in World in 2003?
Make the answer very short. -1.29e+08. What is the difference between the Aid flow from UN agencies (US$) in Arab World in 2000 and the Aid flow from UN agencies (US$) in Lower middle income in 2004?
Provide a succinct answer. -9.30e+05. What is the difference between the Aid flow from UN agencies (US$) of Arab World in 2000 and the Aid flow from UN agencies (US$) of Middle East & North Africa (all income levels) in 2004?
Provide a short and direct response. -1.48e+08. What is the difference between the Aid flow from UN agencies (US$) of Arab World in 2000 and the Aid flow from UN agencies (US$) of World in 2004?
Provide a short and direct response. -1.48e+08. What is the difference between the Aid flow from UN agencies (US$) of Lower middle income in 2000 and the Aid flow from UN agencies (US$) of Middle East & North Africa (all income levels) in 2004?
Ensure brevity in your answer.  -2.74e+08. What is the difference between the Aid flow from UN agencies (US$) in Lower middle income in 2000 and the Aid flow from UN agencies (US$) in World in 2004?
Your answer should be compact. -2.74e+08. What is the difference between the Aid flow from UN agencies (US$) in Middle East & North Africa (all income levels) in 2000 and the Aid flow from UN agencies (US$) in World in 2004?
Offer a very short reply. -1.48e+08. What is the difference between the Aid flow from UN agencies (US$) in Arab World in 2001 and the Aid flow from UN agencies (US$) in Lower middle income in 2002?
Provide a short and direct response. 9.63e+07. What is the difference between the Aid flow from UN agencies (US$) in Arab World in 2001 and the Aid flow from UN agencies (US$) in Middle East & North Africa (all income levels) in 2002?
Provide a short and direct response. -3.28e+07. What is the difference between the Aid flow from UN agencies (US$) in Arab World in 2001 and the Aid flow from UN agencies (US$) in World in 2002?
Offer a very short reply. -3.28e+07. What is the difference between the Aid flow from UN agencies (US$) in Lower middle income in 2001 and the Aid flow from UN agencies (US$) in Middle East & North Africa (all income levels) in 2002?
Offer a very short reply. -1.59e+08. What is the difference between the Aid flow from UN agencies (US$) of Lower middle income in 2001 and the Aid flow from UN agencies (US$) of World in 2002?
Offer a terse response. -1.59e+08. What is the difference between the Aid flow from UN agencies (US$) of Middle East & North Africa (all income levels) in 2001 and the Aid flow from UN agencies (US$) of World in 2002?
Your answer should be very brief. -3.28e+07. What is the difference between the Aid flow from UN agencies (US$) of Arab World in 2001 and the Aid flow from UN agencies (US$) of Lower middle income in 2003?
Ensure brevity in your answer.  6.91e+07. What is the difference between the Aid flow from UN agencies (US$) of Arab World in 2001 and the Aid flow from UN agencies (US$) of Middle East & North Africa (all income levels) in 2003?
Make the answer very short. -7.07e+07. What is the difference between the Aid flow from UN agencies (US$) in Arab World in 2001 and the Aid flow from UN agencies (US$) in World in 2003?
Offer a very short reply. -7.07e+07. What is the difference between the Aid flow from UN agencies (US$) in Lower middle income in 2001 and the Aid flow from UN agencies (US$) in Middle East & North Africa (all income levels) in 2003?
Offer a terse response. -1.97e+08. What is the difference between the Aid flow from UN agencies (US$) of Lower middle income in 2001 and the Aid flow from UN agencies (US$) of World in 2003?
Offer a terse response. -1.97e+08. What is the difference between the Aid flow from UN agencies (US$) of Middle East & North Africa (all income levels) in 2001 and the Aid flow from UN agencies (US$) of World in 2003?
Provide a short and direct response. -7.07e+07. What is the difference between the Aid flow from UN agencies (US$) in Arab World in 2001 and the Aid flow from UN agencies (US$) in Lower middle income in 2004?
Give a very brief answer. 5.77e+07. What is the difference between the Aid flow from UN agencies (US$) in Arab World in 2001 and the Aid flow from UN agencies (US$) in Middle East & North Africa (all income levels) in 2004?
Your answer should be very brief. -8.94e+07. What is the difference between the Aid flow from UN agencies (US$) in Arab World in 2001 and the Aid flow from UN agencies (US$) in World in 2004?
Ensure brevity in your answer.  -8.94e+07. What is the difference between the Aid flow from UN agencies (US$) in Lower middle income in 2001 and the Aid flow from UN agencies (US$) in Middle East & North Africa (all income levels) in 2004?
Give a very brief answer. -2.16e+08. What is the difference between the Aid flow from UN agencies (US$) of Lower middle income in 2001 and the Aid flow from UN agencies (US$) of World in 2004?
Offer a terse response. -2.16e+08. What is the difference between the Aid flow from UN agencies (US$) in Middle East & North Africa (all income levels) in 2001 and the Aid flow from UN agencies (US$) in World in 2004?
Ensure brevity in your answer.  -8.94e+07. What is the difference between the Aid flow from UN agencies (US$) in Arab World in 2002 and the Aid flow from UN agencies (US$) in Lower middle income in 2003?
Give a very brief answer. 1.02e+08. What is the difference between the Aid flow from UN agencies (US$) of Arab World in 2002 and the Aid flow from UN agencies (US$) of Middle East & North Africa (all income levels) in 2003?
Offer a terse response. -3.79e+07. What is the difference between the Aid flow from UN agencies (US$) of Arab World in 2002 and the Aid flow from UN agencies (US$) of World in 2003?
Provide a succinct answer. -3.79e+07. What is the difference between the Aid flow from UN agencies (US$) of Lower middle income in 2002 and the Aid flow from UN agencies (US$) of Middle East & North Africa (all income levels) in 2003?
Provide a short and direct response. -1.67e+08. What is the difference between the Aid flow from UN agencies (US$) of Lower middle income in 2002 and the Aid flow from UN agencies (US$) of World in 2003?
Your answer should be compact. -1.67e+08. What is the difference between the Aid flow from UN agencies (US$) in Middle East & North Africa (all income levels) in 2002 and the Aid flow from UN agencies (US$) in World in 2003?
Provide a short and direct response. -3.79e+07. What is the difference between the Aid flow from UN agencies (US$) in Arab World in 2002 and the Aid flow from UN agencies (US$) in Lower middle income in 2004?
Your response must be concise. 9.05e+07. What is the difference between the Aid flow from UN agencies (US$) in Arab World in 2002 and the Aid flow from UN agencies (US$) in Middle East & North Africa (all income levels) in 2004?
Offer a very short reply. -5.66e+07. What is the difference between the Aid flow from UN agencies (US$) in Arab World in 2002 and the Aid flow from UN agencies (US$) in World in 2004?
Give a very brief answer. -5.66e+07. What is the difference between the Aid flow from UN agencies (US$) of Lower middle income in 2002 and the Aid flow from UN agencies (US$) of Middle East & North Africa (all income levels) in 2004?
Give a very brief answer. -1.86e+08. What is the difference between the Aid flow from UN agencies (US$) in Lower middle income in 2002 and the Aid flow from UN agencies (US$) in World in 2004?
Your response must be concise. -1.86e+08. What is the difference between the Aid flow from UN agencies (US$) of Middle East & North Africa (all income levels) in 2002 and the Aid flow from UN agencies (US$) of World in 2004?
Your answer should be very brief. -5.66e+07. What is the difference between the Aid flow from UN agencies (US$) of Arab World in 2003 and the Aid flow from UN agencies (US$) of Lower middle income in 2004?
Your answer should be compact. 1.28e+08. What is the difference between the Aid flow from UN agencies (US$) of Arab World in 2003 and the Aid flow from UN agencies (US$) of Middle East & North Africa (all income levels) in 2004?
Provide a short and direct response. -1.87e+07. What is the difference between the Aid flow from UN agencies (US$) of Arab World in 2003 and the Aid flow from UN agencies (US$) of World in 2004?
Your answer should be compact. -1.87e+07. What is the difference between the Aid flow from UN agencies (US$) of Lower middle income in 2003 and the Aid flow from UN agencies (US$) of Middle East & North Africa (all income levels) in 2004?
Your answer should be very brief. -1.59e+08. What is the difference between the Aid flow from UN agencies (US$) of Lower middle income in 2003 and the Aid flow from UN agencies (US$) of World in 2004?
Provide a succinct answer. -1.59e+08. What is the difference between the Aid flow from UN agencies (US$) in Middle East & North Africa (all income levels) in 2003 and the Aid flow from UN agencies (US$) in World in 2004?
Keep it short and to the point. -1.87e+07. What is the average Aid flow from UN agencies (US$) in Arab World per year?
Provide a short and direct response. 3.47e+08. What is the average Aid flow from UN agencies (US$) in Lower middle income per year?
Provide a succinct answer. 2.18e+08. What is the average Aid flow from UN agencies (US$) in Middle East & North Africa (all income levels) per year?
Make the answer very short. 3.47e+08. What is the average Aid flow from UN agencies (US$) in World per year?
Give a very brief answer. 3.47e+08. In the year 1997, what is the difference between the Aid flow from UN agencies (US$) of Arab World and Aid flow from UN agencies (US$) of Lower middle income?
Keep it short and to the point. 1.18e+08. In the year 1997, what is the difference between the Aid flow from UN agencies (US$) in Arab World and Aid flow from UN agencies (US$) in Middle East & North Africa (all income levels)?
Offer a terse response. 0. In the year 1997, what is the difference between the Aid flow from UN agencies (US$) in Arab World and Aid flow from UN agencies (US$) in World?
Make the answer very short. 0. In the year 1997, what is the difference between the Aid flow from UN agencies (US$) of Lower middle income and Aid flow from UN agencies (US$) of Middle East & North Africa (all income levels)?
Your answer should be very brief. -1.18e+08. In the year 1997, what is the difference between the Aid flow from UN agencies (US$) in Lower middle income and Aid flow from UN agencies (US$) in World?
Your answer should be compact. -1.18e+08. In the year 1998, what is the difference between the Aid flow from UN agencies (US$) in Arab World and Aid flow from UN agencies (US$) in Lower middle income?
Offer a terse response. 1.23e+08. In the year 1998, what is the difference between the Aid flow from UN agencies (US$) in Lower middle income and Aid flow from UN agencies (US$) in Middle East & North Africa (all income levels)?
Make the answer very short. -1.23e+08. In the year 1998, what is the difference between the Aid flow from UN agencies (US$) of Lower middle income and Aid flow from UN agencies (US$) of World?
Provide a succinct answer. -1.23e+08. In the year 1999, what is the difference between the Aid flow from UN agencies (US$) in Arab World and Aid flow from UN agencies (US$) in Lower middle income?
Keep it short and to the point. 1.26e+08. In the year 1999, what is the difference between the Aid flow from UN agencies (US$) in Arab World and Aid flow from UN agencies (US$) in Middle East & North Africa (all income levels)?
Your answer should be very brief. 0. In the year 1999, what is the difference between the Aid flow from UN agencies (US$) in Lower middle income and Aid flow from UN agencies (US$) in Middle East & North Africa (all income levels)?
Provide a succinct answer. -1.26e+08. In the year 1999, what is the difference between the Aid flow from UN agencies (US$) of Lower middle income and Aid flow from UN agencies (US$) of World?
Make the answer very short. -1.26e+08. In the year 1999, what is the difference between the Aid flow from UN agencies (US$) in Middle East & North Africa (all income levels) and Aid flow from UN agencies (US$) in World?
Make the answer very short. 0. In the year 2000, what is the difference between the Aid flow from UN agencies (US$) in Arab World and Aid flow from UN agencies (US$) in Lower middle income?
Your answer should be compact. 1.26e+08. In the year 2000, what is the difference between the Aid flow from UN agencies (US$) of Arab World and Aid flow from UN agencies (US$) of World?
Your response must be concise. 0. In the year 2000, what is the difference between the Aid flow from UN agencies (US$) of Lower middle income and Aid flow from UN agencies (US$) of Middle East & North Africa (all income levels)?
Offer a terse response. -1.26e+08. In the year 2000, what is the difference between the Aid flow from UN agencies (US$) in Lower middle income and Aid flow from UN agencies (US$) in World?
Give a very brief answer. -1.26e+08. In the year 2000, what is the difference between the Aid flow from UN agencies (US$) in Middle East & North Africa (all income levels) and Aid flow from UN agencies (US$) in World?
Provide a succinct answer. 0. In the year 2001, what is the difference between the Aid flow from UN agencies (US$) in Arab World and Aid flow from UN agencies (US$) in Lower middle income?
Your response must be concise. 1.27e+08. In the year 2001, what is the difference between the Aid flow from UN agencies (US$) of Lower middle income and Aid flow from UN agencies (US$) of Middle East & North Africa (all income levels)?
Your answer should be compact. -1.27e+08. In the year 2001, what is the difference between the Aid flow from UN agencies (US$) in Lower middle income and Aid flow from UN agencies (US$) in World?
Make the answer very short. -1.27e+08. In the year 2002, what is the difference between the Aid flow from UN agencies (US$) in Arab World and Aid flow from UN agencies (US$) in Lower middle income?
Ensure brevity in your answer.  1.29e+08. In the year 2002, what is the difference between the Aid flow from UN agencies (US$) in Arab World and Aid flow from UN agencies (US$) in Middle East & North Africa (all income levels)?
Your answer should be compact. 0. In the year 2002, what is the difference between the Aid flow from UN agencies (US$) in Lower middle income and Aid flow from UN agencies (US$) in Middle East & North Africa (all income levels)?
Give a very brief answer. -1.29e+08. In the year 2002, what is the difference between the Aid flow from UN agencies (US$) of Lower middle income and Aid flow from UN agencies (US$) of World?
Give a very brief answer. -1.29e+08. In the year 2002, what is the difference between the Aid flow from UN agencies (US$) in Middle East & North Africa (all income levels) and Aid flow from UN agencies (US$) in World?
Keep it short and to the point. 0. In the year 2003, what is the difference between the Aid flow from UN agencies (US$) in Arab World and Aid flow from UN agencies (US$) in Lower middle income?
Provide a succinct answer. 1.40e+08. In the year 2003, what is the difference between the Aid flow from UN agencies (US$) of Arab World and Aid flow from UN agencies (US$) of World?
Ensure brevity in your answer.  0. In the year 2003, what is the difference between the Aid flow from UN agencies (US$) in Lower middle income and Aid flow from UN agencies (US$) in Middle East & North Africa (all income levels)?
Provide a short and direct response. -1.40e+08. In the year 2003, what is the difference between the Aid flow from UN agencies (US$) of Lower middle income and Aid flow from UN agencies (US$) of World?
Offer a very short reply. -1.40e+08. In the year 2004, what is the difference between the Aid flow from UN agencies (US$) in Arab World and Aid flow from UN agencies (US$) in Lower middle income?
Give a very brief answer. 1.47e+08. In the year 2004, what is the difference between the Aid flow from UN agencies (US$) in Arab World and Aid flow from UN agencies (US$) in Middle East & North Africa (all income levels)?
Ensure brevity in your answer.  0. In the year 2004, what is the difference between the Aid flow from UN agencies (US$) in Arab World and Aid flow from UN agencies (US$) in World?
Make the answer very short. 0. In the year 2004, what is the difference between the Aid flow from UN agencies (US$) in Lower middle income and Aid flow from UN agencies (US$) in Middle East & North Africa (all income levels)?
Your response must be concise. -1.47e+08. In the year 2004, what is the difference between the Aid flow from UN agencies (US$) in Lower middle income and Aid flow from UN agencies (US$) in World?
Offer a very short reply. -1.47e+08. What is the ratio of the Aid flow from UN agencies (US$) in Arab World in 1997 to that in 1998?
Provide a short and direct response. 0.88. What is the ratio of the Aid flow from UN agencies (US$) of Lower middle income in 1997 to that in 1998?
Your answer should be very brief. 0.83. What is the ratio of the Aid flow from UN agencies (US$) of Middle East & North Africa (all income levels) in 1997 to that in 1998?
Offer a very short reply. 0.88. What is the ratio of the Aid flow from UN agencies (US$) of World in 1997 to that in 1998?
Keep it short and to the point. 0.88. What is the ratio of the Aid flow from UN agencies (US$) in Arab World in 1997 to that in 1999?
Make the answer very short. 0.92. What is the ratio of the Aid flow from UN agencies (US$) in Lower middle income in 1997 to that in 1999?
Your response must be concise. 0.91. What is the ratio of the Aid flow from UN agencies (US$) of Middle East & North Africa (all income levels) in 1997 to that in 1999?
Your answer should be very brief. 0.92. What is the ratio of the Aid flow from UN agencies (US$) in World in 1997 to that in 1999?
Your response must be concise. 0.92. What is the ratio of the Aid flow from UN agencies (US$) in Arab World in 1997 to that in 2000?
Provide a short and direct response. 0.88. What is the ratio of the Aid flow from UN agencies (US$) in Lower middle income in 1997 to that in 2000?
Offer a very short reply. 0.84. What is the ratio of the Aid flow from UN agencies (US$) of Middle East & North Africa (all income levels) in 1997 to that in 2000?
Your answer should be compact. 0.88. What is the ratio of the Aid flow from UN agencies (US$) in World in 1997 to that in 2000?
Offer a very short reply. 0.88. What is the ratio of the Aid flow from UN agencies (US$) of Arab World in 1997 to that in 2001?
Provide a succinct answer. 0.73. What is the ratio of the Aid flow from UN agencies (US$) of Lower middle income in 1997 to that in 2001?
Provide a succinct answer. 0.63. What is the ratio of the Aid flow from UN agencies (US$) of Middle East & North Africa (all income levels) in 1997 to that in 2001?
Offer a terse response. 0.73. What is the ratio of the Aid flow from UN agencies (US$) in World in 1997 to that in 2001?
Your answer should be very brief. 0.73. What is the ratio of the Aid flow from UN agencies (US$) in Arab World in 1997 to that in 2002?
Keep it short and to the point. 0.67. What is the ratio of the Aid flow from UN agencies (US$) in Lower middle income in 1997 to that in 2002?
Offer a terse response. 0.55. What is the ratio of the Aid flow from UN agencies (US$) in Middle East & North Africa (all income levels) in 1997 to that in 2002?
Ensure brevity in your answer.  0.67. What is the ratio of the Aid flow from UN agencies (US$) in World in 1997 to that in 2002?
Give a very brief answer. 0.67. What is the ratio of the Aid flow from UN agencies (US$) in Arab World in 1997 to that in 2003?
Provide a short and direct response. 0.61. What is the ratio of the Aid flow from UN agencies (US$) of Lower middle income in 1997 to that in 2003?
Make the answer very short. 0.5. What is the ratio of the Aid flow from UN agencies (US$) in Middle East & North Africa (all income levels) in 1997 to that in 2003?
Offer a very short reply. 0.61. What is the ratio of the Aid flow from UN agencies (US$) of World in 1997 to that in 2003?
Ensure brevity in your answer.  0.61. What is the ratio of the Aid flow from UN agencies (US$) in Arab World in 1997 to that in 2004?
Your response must be concise. 0.59. What is the ratio of the Aid flow from UN agencies (US$) in Lower middle income in 1997 to that in 2004?
Provide a succinct answer. 0.48. What is the ratio of the Aid flow from UN agencies (US$) of Middle East & North Africa (all income levels) in 1997 to that in 2004?
Ensure brevity in your answer.  0.59. What is the ratio of the Aid flow from UN agencies (US$) in World in 1997 to that in 2004?
Keep it short and to the point. 0.59. What is the ratio of the Aid flow from UN agencies (US$) of Arab World in 1998 to that in 1999?
Give a very brief answer. 1.04. What is the ratio of the Aid flow from UN agencies (US$) in Lower middle income in 1998 to that in 1999?
Offer a very short reply. 1.09. What is the ratio of the Aid flow from UN agencies (US$) in Middle East & North Africa (all income levels) in 1998 to that in 1999?
Your response must be concise. 1.04. What is the ratio of the Aid flow from UN agencies (US$) of World in 1998 to that in 1999?
Offer a very short reply. 1.04. What is the ratio of the Aid flow from UN agencies (US$) in Arab World in 1998 to that in 2000?
Keep it short and to the point. 0.99. What is the ratio of the Aid flow from UN agencies (US$) in Lower middle income in 1998 to that in 2000?
Offer a terse response. 1. What is the ratio of the Aid flow from UN agencies (US$) in World in 1998 to that in 2000?
Your answer should be very brief. 0.99. What is the ratio of the Aid flow from UN agencies (US$) of Arab World in 1998 to that in 2001?
Give a very brief answer. 0.83. What is the ratio of the Aid flow from UN agencies (US$) of Lower middle income in 1998 to that in 2001?
Make the answer very short. 0.75. What is the ratio of the Aid flow from UN agencies (US$) in Middle East & North Africa (all income levels) in 1998 to that in 2001?
Provide a short and direct response. 0.83. What is the ratio of the Aid flow from UN agencies (US$) of World in 1998 to that in 2001?
Make the answer very short. 0.83. What is the ratio of the Aid flow from UN agencies (US$) of Arab World in 1998 to that in 2002?
Your answer should be compact. 0.76. What is the ratio of the Aid flow from UN agencies (US$) in Lower middle income in 1998 to that in 2002?
Offer a very short reply. 0.67. What is the ratio of the Aid flow from UN agencies (US$) in Middle East & North Africa (all income levels) in 1998 to that in 2002?
Your answer should be compact. 0.76. What is the ratio of the Aid flow from UN agencies (US$) in World in 1998 to that in 2002?
Provide a succinct answer. 0.76. What is the ratio of the Aid flow from UN agencies (US$) in Arab World in 1998 to that in 2003?
Ensure brevity in your answer.  0.69. What is the ratio of the Aid flow from UN agencies (US$) of Lower middle income in 1998 to that in 2003?
Your answer should be very brief. 0.6. What is the ratio of the Aid flow from UN agencies (US$) of Middle East & North Africa (all income levels) in 1998 to that in 2003?
Ensure brevity in your answer.  0.69. What is the ratio of the Aid flow from UN agencies (US$) of World in 1998 to that in 2003?
Provide a short and direct response. 0.69. What is the ratio of the Aid flow from UN agencies (US$) in Arab World in 1998 to that in 2004?
Provide a succinct answer. 0.66. What is the ratio of the Aid flow from UN agencies (US$) in Lower middle income in 1998 to that in 2004?
Your answer should be compact. 0.58. What is the ratio of the Aid flow from UN agencies (US$) in Middle East & North Africa (all income levels) in 1998 to that in 2004?
Give a very brief answer. 0.66. What is the ratio of the Aid flow from UN agencies (US$) of World in 1998 to that in 2004?
Your answer should be very brief. 0.66. What is the ratio of the Aid flow from UN agencies (US$) of Arab World in 1999 to that in 2000?
Your response must be concise. 0.95. What is the ratio of the Aid flow from UN agencies (US$) in Lower middle income in 1999 to that in 2000?
Your answer should be compact. 0.92. What is the ratio of the Aid flow from UN agencies (US$) of Middle East & North Africa (all income levels) in 1999 to that in 2000?
Give a very brief answer. 0.95. What is the ratio of the Aid flow from UN agencies (US$) of World in 1999 to that in 2000?
Your response must be concise. 0.95. What is the ratio of the Aid flow from UN agencies (US$) of Arab World in 1999 to that in 2001?
Your answer should be very brief. 0.8. What is the ratio of the Aid flow from UN agencies (US$) of Lower middle income in 1999 to that in 2001?
Your answer should be very brief. 0.69. What is the ratio of the Aid flow from UN agencies (US$) in Middle East & North Africa (all income levels) in 1999 to that in 2001?
Your answer should be compact. 0.8. What is the ratio of the Aid flow from UN agencies (US$) of World in 1999 to that in 2001?
Give a very brief answer. 0.8. What is the ratio of the Aid flow from UN agencies (US$) of Arab World in 1999 to that in 2002?
Keep it short and to the point. 0.73. What is the ratio of the Aid flow from UN agencies (US$) in Lower middle income in 1999 to that in 2002?
Your response must be concise. 0.61. What is the ratio of the Aid flow from UN agencies (US$) in Middle East & North Africa (all income levels) in 1999 to that in 2002?
Offer a terse response. 0.73. What is the ratio of the Aid flow from UN agencies (US$) in World in 1999 to that in 2002?
Provide a short and direct response. 0.73. What is the ratio of the Aid flow from UN agencies (US$) in Arab World in 1999 to that in 2003?
Offer a very short reply. 0.67. What is the ratio of the Aid flow from UN agencies (US$) of Lower middle income in 1999 to that in 2003?
Offer a terse response. 0.55. What is the ratio of the Aid flow from UN agencies (US$) in Middle East & North Africa (all income levels) in 1999 to that in 2003?
Provide a succinct answer. 0.67. What is the ratio of the Aid flow from UN agencies (US$) in World in 1999 to that in 2003?
Keep it short and to the point. 0.67. What is the ratio of the Aid flow from UN agencies (US$) in Arab World in 1999 to that in 2004?
Your response must be concise. 0.64. What is the ratio of the Aid flow from UN agencies (US$) in Lower middle income in 1999 to that in 2004?
Your answer should be compact. 0.53. What is the ratio of the Aid flow from UN agencies (US$) of Middle East & North Africa (all income levels) in 1999 to that in 2004?
Make the answer very short. 0.64. What is the ratio of the Aid flow from UN agencies (US$) in World in 1999 to that in 2004?
Provide a short and direct response. 0.64. What is the ratio of the Aid flow from UN agencies (US$) of Arab World in 2000 to that in 2001?
Provide a short and direct response. 0.84. What is the ratio of the Aid flow from UN agencies (US$) in Lower middle income in 2000 to that in 2001?
Make the answer very short. 0.75. What is the ratio of the Aid flow from UN agencies (US$) of Middle East & North Africa (all income levels) in 2000 to that in 2001?
Provide a short and direct response. 0.84. What is the ratio of the Aid flow from UN agencies (US$) in World in 2000 to that in 2001?
Keep it short and to the point. 0.84. What is the ratio of the Aid flow from UN agencies (US$) of Arab World in 2000 to that in 2002?
Provide a succinct answer. 0.77. What is the ratio of the Aid flow from UN agencies (US$) in Lower middle income in 2000 to that in 2002?
Keep it short and to the point. 0.66. What is the ratio of the Aid flow from UN agencies (US$) in Middle East & North Africa (all income levels) in 2000 to that in 2002?
Keep it short and to the point. 0.77. What is the ratio of the Aid flow from UN agencies (US$) of World in 2000 to that in 2002?
Your answer should be very brief. 0.77. What is the ratio of the Aid flow from UN agencies (US$) of Arab World in 2000 to that in 2003?
Make the answer very short. 0.7. What is the ratio of the Aid flow from UN agencies (US$) of Lower middle income in 2000 to that in 2003?
Provide a short and direct response. 0.6. What is the ratio of the Aid flow from UN agencies (US$) of Middle East & North Africa (all income levels) in 2000 to that in 2003?
Offer a terse response. 0.7. What is the ratio of the Aid flow from UN agencies (US$) in World in 2000 to that in 2003?
Offer a terse response. 0.7. What is the ratio of the Aid flow from UN agencies (US$) in Arab World in 2000 to that in 2004?
Your response must be concise. 0.67. What is the ratio of the Aid flow from UN agencies (US$) of Lower middle income in 2000 to that in 2004?
Your answer should be very brief. 0.58. What is the ratio of the Aid flow from UN agencies (US$) in Middle East & North Africa (all income levels) in 2000 to that in 2004?
Provide a short and direct response. 0.67. What is the ratio of the Aid flow from UN agencies (US$) in World in 2000 to that in 2004?
Provide a short and direct response. 0.67. What is the ratio of the Aid flow from UN agencies (US$) in Arab World in 2001 to that in 2002?
Provide a short and direct response. 0.92. What is the ratio of the Aid flow from UN agencies (US$) in Lower middle income in 2001 to that in 2002?
Make the answer very short. 0.88. What is the ratio of the Aid flow from UN agencies (US$) of Middle East & North Africa (all income levels) in 2001 to that in 2002?
Provide a succinct answer. 0.92. What is the ratio of the Aid flow from UN agencies (US$) of World in 2001 to that in 2002?
Give a very brief answer. 0.92. What is the ratio of the Aid flow from UN agencies (US$) of Arab World in 2001 to that in 2003?
Your answer should be very brief. 0.84. What is the ratio of the Aid flow from UN agencies (US$) of Lower middle income in 2001 to that in 2003?
Offer a very short reply. 0.8. What is the ratio of the Aid flow from UN agencies (US$) in Middle East & North Africa (all income levels) in 2001 to that in 2003?
Keep it short and to the point. 0.84. What is the ratio of the Aid flow from UN agencies (US$) of World in 2001 to that in 2003?
Offer a terse response. 0.84. What is the ratio of the Aid flow from UN agencies (US$) in Arab World in 2001 to that in 2004?
Your answer should be very brief. 0.8. What is the ratio of the Aid flow from UN agencies (US$) in Lower middle income in 2001 to that in 2004?
Your response must be concise. 0.77. What is the ratio of the Aid flow from UN agencies (US$) in Middle East & North Africa (all income levels) in 2001 to that in 2004?
Your answer should be compact. 0.8. What is the ratio of the Aid flow from UN agencies (US$) in World in 2001 to that in 2004?
Give a very brief answer. 0.8. What is the ratio of the Aid flow from UN agencies (US$) in Arab World in 2002 to that in 2003?
Your answer should be very brief. 0.91. What is the ratio of the Aid flow from UN agencies (US$) in Lower middle income in 2002 to that in 2003?
Ensure brevity in your answer.  0.91. What is the ratio of the Aid flow from UN agencies (US$) of Middle East & North Africa (all income levels) in 2002 to that in 2003?
Make the answer very short. 0.91. What is the ratio of the Aid flow from UN agencies (US$) in World in 2002 to that in 2003?
Offer a very short reply. 0.91. What is the ratio of the Aid flow from UN agencies (US$) in Arab World in 2002 to that in 2004?
Give a very brief answer. 0.87. What is the ratio of the Aid flow from UN agencies (US$) in Lower middle income in 2002 to that in 2004?
Offer a very short reply. 0.87. What is the ratio of the Aid flow from UN agencies (US$) of Middle East & North Africa (all income levels) in 2002 to that in 2004?
Offer a terse response. 0.87. What is the ratio of the Aid flow from UN agencies (US$) of World in 2002 to that in 2004?
Your response must be concise. 0.87. What is the ratio of the Aid flow from UN agencies (US$) of World in 2003 to that in 2004?
Provide a succinct answer. 0.96. What is the difference between the highest and the second highest Aid flow from UN agencies (US$) of Arab World?
Keep it short and to the point. 1.87e+07. What is the difference between the highest and the second highest Aid flow from UN agencies (US$) in Lower middle income?
Offer a very short reply. 1.15e+07. What is the difference between the highest and the second highest Aid flow from UN agencies (US$) of Middle East & North Africa (all income levels)?
Offer a very short reply. 1.87e+07. What is the difference between the highest and the second highest Aid flow from UN agencies (US$) of World?
Make the answer very short. 1.87e+07. What is the difference between the highest and the lowest Aid flow from UN agencies (US$) in Arab World?
Keep it short and to the point. 1.85e+08. What is the difference between the highest and the lowest Aid flow from UN agencies (US$) in Lower middle income?
Your response must be concise. 1.56e+08. What is the difference between the highest and the lowest Aid flow from UN agencies (US$) in Middle East & North Africa (all income levels)?
Keep it short and to the point. 1.85e+08. What is the difference between the highest and the lowest Aid flow from UN agencies (US$) of World?
Provide a short and direct response. 1.85e+08. 